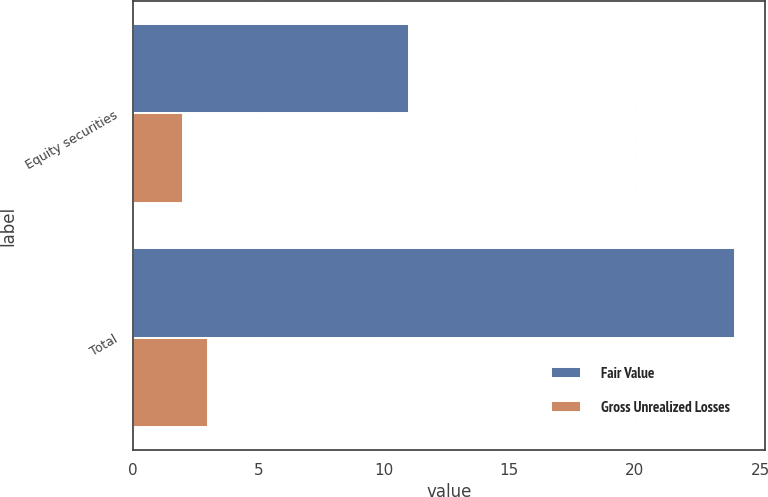Convert chart. <chart><loc_0><loc_0><loc_500><loc_500><stacked_bar_chart><ecel><fcel>Equity securities<fcel>Total<nl><fcel>Fair Value<fcel>11<fcel>24<nl><fcel>Gross Unrealized Losses<fcel>2<fcel>3<nl></chart> 